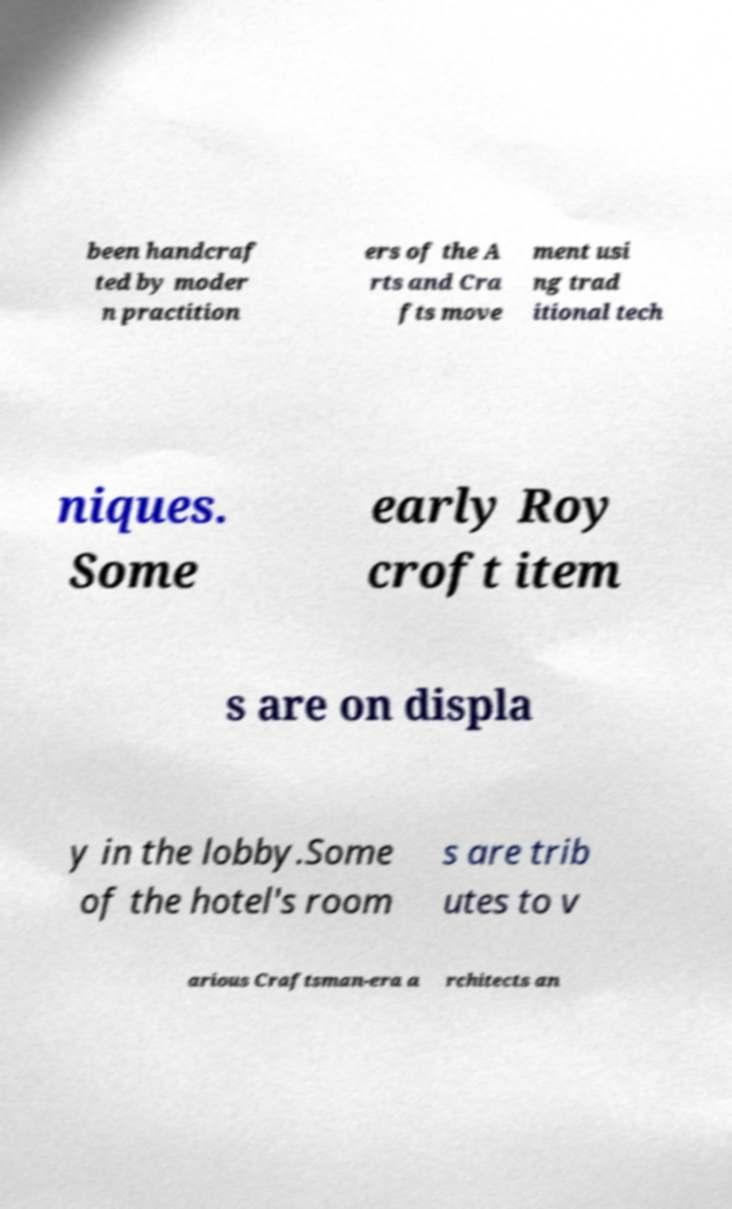Could you extract and type out the text from this image? been handcraf ted by moder n practition ers of the A rts and Cra fts move ment usi ng trad itional tech niques. Some early Roy croft item s are on displa y in the lobby.Some of the hotel's room s are trib utes to v arious Craftsman-era a rchitects an 